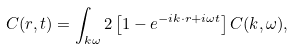<formula> <loc_0><loc_0><loc_500><loc_500>C ( { r } , t ) = \int _ { { k } \omega } 2 \left [ 1 - e ^ { - i { k \cdot r } + i \omega t } \right ] C ( { k } , \omega ) ,</formula> 